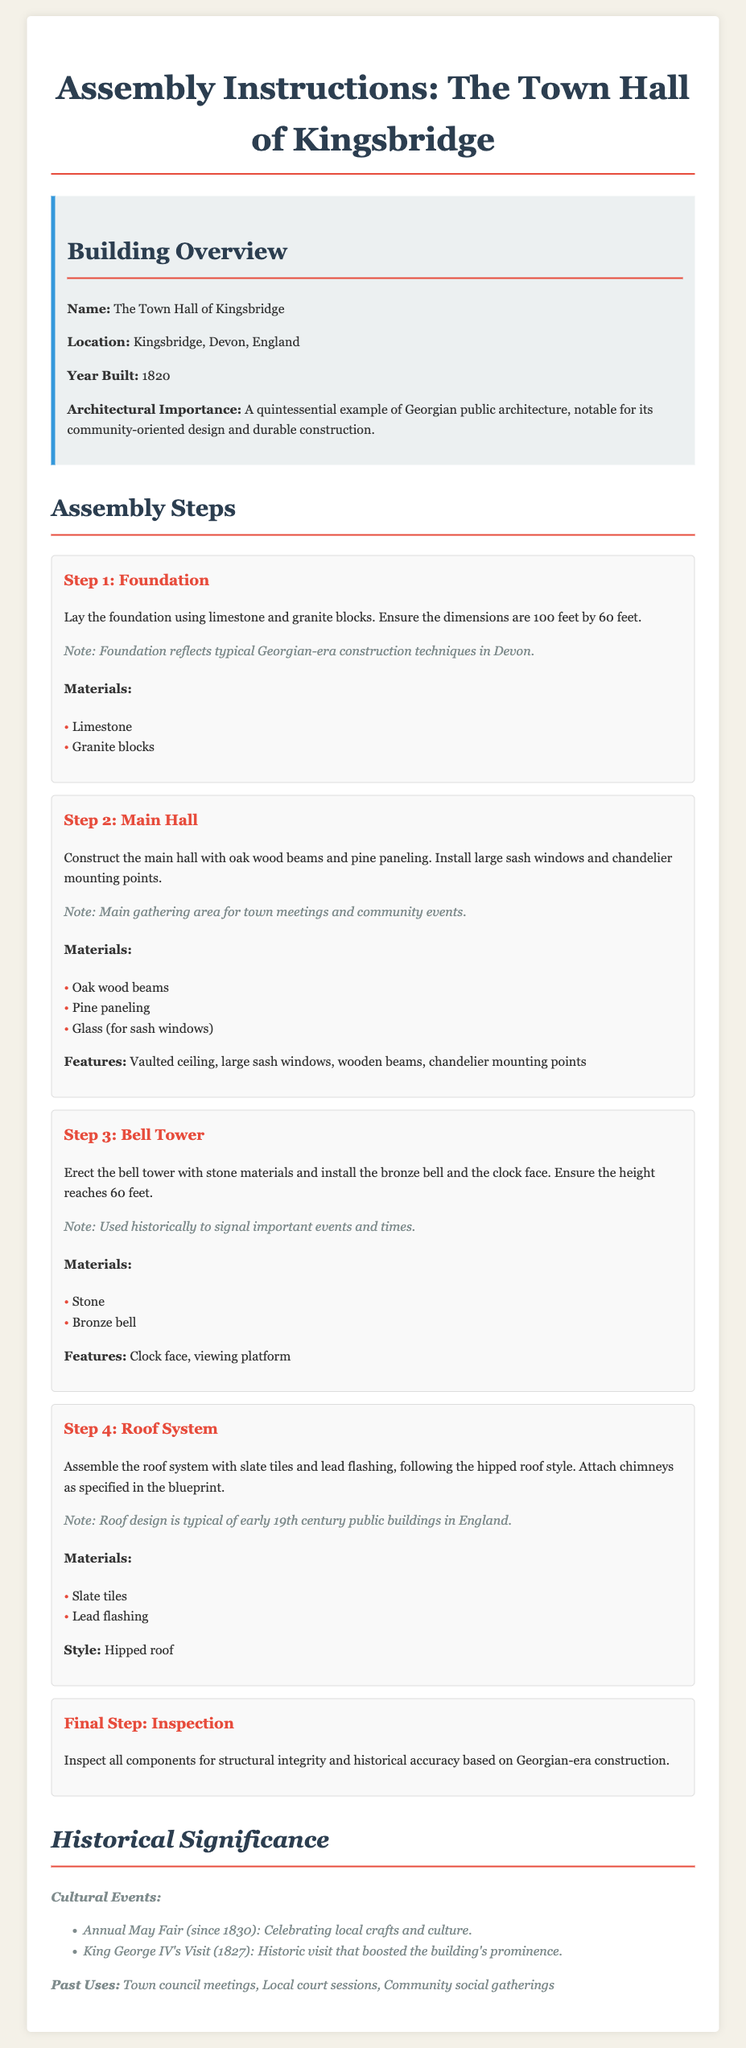What year was the Town Hall built? The document states that the year built for the Town Hall of Kingsbridge is 1820.
Answer: 1820 What materials are used for the foundation? The foundation is made of limestone and granite blocks as mentioned in Step 1.
Answer: Limestone and granite blocks What is the height of the bell tower? The bell tower is specified to reach a height of 60 feet in Step 3.
Answer: 60 feet What significant cultural event started in 1830? The document mentions the Annual May Fair as a cultural event that began in 1830.
Answer: Annual May Fair What is the architectural style of the roof system? The roof system is described as following the hipped roof style in Step 4.
Answer: Hipped roof What type of wood is used for the main hall? According to Step 2, the main hall is constructed with oak wood beams.
Answer: Oak wood beams What was the purpose of the bell tower historically? Historically, the bell tower was used to signal important events and times, as noted in Step 3.
Answer: Signal important events and times What is a notable feature of the main hall? A notable feature mentioned for the main hall includes large sash windows.
Answer: Large sash windows What architectural importance is noted for the Town Hall? The document states it is a quintessential example of Georgian public architecture.
Answer: Quintessential example of Georgian public architecture 